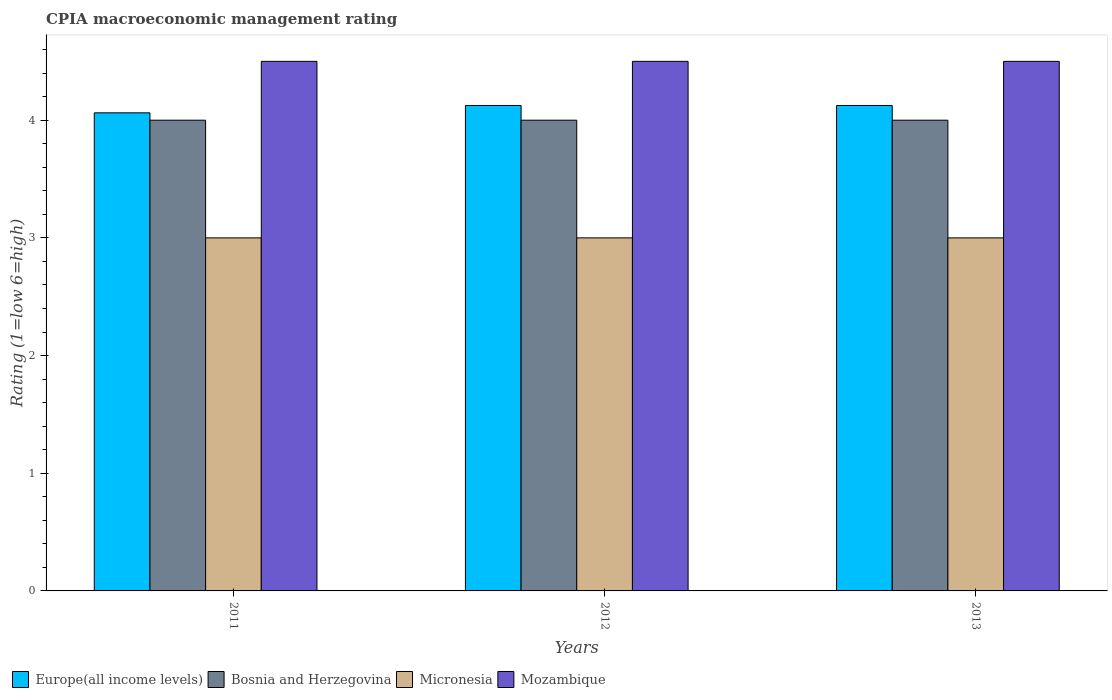Are the number of bars per tick equal to the number of legend labels?
Your answer should be compact. Yes. Are the number of bars on each tick of the X-axis equal?
Ensure brevity in your answer.  Yes. In how many cases, is the number of bars for a given year not equal to the number of legend labels?
Offer a very short reply. 0. What is the CPIA rating in Micronesia in 2011?
Your answer should be very brief. 3. Across all years, what is the maximum CPIA rating in Europe(all income levels)?
Provide a succinct answer. 4.12. What is the total CPIA rating in Bosnia and Herzegovina in the graph?
Provide a short and direct response. 12. What is the difference between the CPIA rating in Micronesia in 2011 and that in 2012?
Give a very brief answer. 0. What is the difference between the CPIA rating in Mozambique in 2012 and the CPIA rating in Micronesia in 2013?
Make the answer very short. 1.5. What is the average CPIA rating in Micronesia per year?
Your response must be concise. 3. In the year 2011, what is the difference between the CPIA rating in Bosnia and Herzegovina and CPIA rating in Europe(all income levels)?
Make the answer very short. -0.06. In how many years, is the CPIA rating in Bosnia and Herzegovina greater than 2.6?
Provide a short and direct response. 3. What is the difference between the highest and the second highest CPIA rating in Bosnia and Herzegovina?
Keep it short and to the point. 0. What is the difference between the highest and the lowest CPIA rating in Europe(all income levels)?
Offer a terse response. 0.06. In how many years, is the CPIA rating in Bosnia and Herzegovina greater than the average CPIA rating in Bosnia and Herzegovina taken over all years?
Your response must be concise. 0. Is it the case that in every year, the sum of the CPIA rating in Mozambique and CPIA rating in Bosnia and Herzegovina is greater than the sum of CPIA rating in Europe(all income levels) and CPIA rating in Micronesia?
Provide a short and direct response. Yes. What does the 2nd bar from the left in 2011 represents?
Offer a very short reply. Bosnia and Herzegovina. What does the 1st bar from the right in 2012 represents?
Make the answer very short. Mozambique. Is it the case that in every year, the sum of the CPIA rating in Mozambique and CPIA rating in Europe(all income levels) is greater than the CPIA rating in Bosnia and Herzegovina?
Your response must be concise. Yes. How many bars are there?
Offer a terse response. 12. How many years are there in the graph?
Ensure brevity in your answer.  3. Are the values on the major ticks of Y-axis written in scientific E-notation?
Your answer should be very brief. No. Does the graph contain grids?
Make the answer very short. No. Where does the legend appear in the graph?
Provide a succinct answer. Bottom left. What is the title of the graph?
Offer a terse response. CPIA macroeconomic management rating. Does "Lao PDR" appear as one of the legend labels in the graph?
Give a very brief answer. No. What is the label or title of the X-axis?
Your answer should be very brief. Years. What is the label or title of the Y-axis?
Provide a short and direct response. Rating (1=low 6=high). What is the Rating (1=low 6=high) of Europe(all income levels) in 2011?
Make the answer very short. 4.06. What is the Rating (1=low 6=high) of Europe(all income levels) in 2012?
Keep it short and to the point. 4.12. What is the Rating (1=low 6=high) in Micronesia in 2012?
Provide a short and direct response. 3. What is the Rating (1=low 6=high) in Europe(all income levels) in 2013?
Your answer should be very brief. 4.12. Across all years, what is the maximum Rating (1=low 6=high) of Europe(all income levels)?
Ensure brevity in your answer.  4.12. Across all years, what is the minimum Rating (1=low 6=high) of Europe(all income levels)?
Keep it short and to the point. 4.06. Across all years, what is the minimum Rating (1=low 6=high) in Bosnia and Herzegovina?
Keep it short and to the point. 4. What is the total Rating (1=low 6=high) in Europe(all income levels) in the graph?
Provide a succinct answer. 12.31. What is the total Rating (1=low 6=high) in Bosnia and Herzegovina in the graph?
Offer a terse response. 12. What is the total Rating (1=low 6=high) of Micronesia in the graph?
Your response must be concise. 9. What is the total Rating (1=low 6=high) in Mozambique in the graph?
Your response must be concise. 13.5. What is the difference between the Rating (1=low 6=high) in Europe(all income levels) in 2011 and that in 2012?
Make the answer very short. -0.06. What is the difference between the Rating (1=low 6=high) in Micronesia in 2011 and that in 2012?
Keep it short and to the point. 0. What is the difference between the Rating (1=low 6=high) of Mozambique in 2011 and that in 2012?
Provide a short and direct response. 0. What is the difference between the Rating (1=low 6=high) in Europe(all income levels) in 2011 and that in 2013?
Offer a terse response. -0.06. What is the difference between the Rating (1=low 6=high) of Bosnia and Herzegovina in 2011 and that in 2013?
Make the answer very short. 0. What is the difference between the Rating (1=low 6=high) of Micronesia in 2011 and that in 2013?
Offer a very short reply. 0. What is the difference between the Rating (1=low 6=high) in Europe(all income levels) in 2012 and that in 2013?
Offer a very short reply. 0. What is the difference between the Rating (1=low 6=high) of Bosnia and Herzegovina in 2012 and that in 2013?
Give a very brief answer. 0. What is the difference between the Rating (1=low 6=high) in Europe(all income levels) in 2011 and the Rating (1=low 6=high) in Bosnia and Herzegovina in 2012?
Keep it short and to the point. 0.06. What is the difference between the Rating (1=low 6=high) in Europe(all income levels) in 2011 and the Rating (1=low 6=high) in Mozambique in 2012?
Give a very brief answer. -0.44. What is the difference between the Rating (1=low 6=high) in Europe(all income levels) in 2011 and the Rating (1=low 6=high) in Bosnia and Herzegovina in 2013?
Your answer should be very brief. 0.06. What is the difference between the Rating (1=low 6=high) in Europe(all income levels) in 2011 and the Rating (1=low 6=high) in Micronesia in 2013?
Make the answer very short. 1.06. What is the difference between the Rating (1=low 6=high) of Europe(all income levels) in 2011 and the Rating (1=low 6=high) of Mozambique in 2013?
Offer a very short reply. -0.44. What is the difference between the Rating (1=low 6=high) in Bosnia and Herzegovina in 2011 and the Rating (1=low 6=high) in Micronesia in 2013?
Ensure brevity in your answer.  1. What is the difference between the Rating (1=low 6=high) of Europe(all income levels) in 2012 and the Rating (1=low 6=high) of Bosnia and Herzegovina in 2013?
Ensure brevity in your answer.  0.12. What is the difference between the Rating (1=low 6=high) in Europe(all income levels) in 2012 and the Rating (1=low 6=high) in Micronesia in 2013?
Provide a succinct answer. 1.12. What is the difference between the Rating (1=low 6=high) of Europe(all income levels) in 2012 and the Rating (1=low 6=high) of Mozambique in 2013?
Provide a short and direct response. -0.38. What is the difference between the Rating (1=low 6=high) in Micronesia in 2012 and the Rating (1=low 6=high) in Mozambique in 2013?
Provide a succinct answer. -1.5. What is the average Rating (1=low 6=high) of Europe(all income levels) per year?
Your answer should be compact. 4.1. In the year 2011, what is the difference between the Rating (1=low 6=high) of Europe(all income levels) and Rating (1=low 6=high) of Bosnia and Herzegovina?
Offer a very short reply. 0.06. In the year 2011, what is the difference between the Rating (1=low 6=high) of Europe(all income levels) and Rating (1=low 6=high) of Micronesia?
Provide a short and direct response. 1.06. In the year 2011, what is the difference between the Rating (1=low 6=high) of Europe(all income levels) and Rating (1=low 6=high) of Mozambique?
Give a very brief answer. -0.44. In the year 2011, what is the difference between the Rating (1=low 6=high) of Bosnia and Herzegovina and Rating (1=low 6=high) of Micronesia?
Your answer should be very brief. 1. In the year 2011, what is the difference between the Rating (1=low 6=high) in Bosnia and Herzegovina and Rating (1=low 6=high) in Mozambique?
Offer a terse response. -0.5. In the year 2012, what is the difference between the Rating (1=low 6=high) in Europe(all income levels) and Rating (1=low 6=high) in Micronesia?
Provide a short and direct response. 1.12. In the year 2012, what is the difference between the Rating (1=low 6=high) in Europe(all income levels) and Rating (1=low 6=high) in Mozambique?
Provide a succinct answer. -0.38. In the year 2012, what is the difference between the Rating (1=low 6=high) in Bosnia and Herzegovina and Rating (1=low 6=high) in Micronesia?
Your answer should be compact. 1. In the year 2012, what is the difference between the Rating (1=low 6=high) in Micronesia and Rating (1=low 6=high) in Mozambique?
Make the answer very short. -1.5. In the year 2013, what is the difference between the Rating (1=low 6=high) of Europe(all income levels) and Rating (1=low 6=high) of Bosnia and Herzegovina?
Your answer should be compact. 0.12. In the year 2013, what is the difference between the Rating (1=low 6=high) of Europe(all income levels) and Rating (1=low 6=high) of Mozambique?
Ensure brevity in your answer.  -0.38. In the year 2013, what is the difference between the Rating (1=low 6=high) in Bosnia and Herzegovina and Rating (1=low 6=high) in Mozambique?
Your response must be concise. -0.5. In the year 2013, what is the difference between the Rating (1=low 6=high) of Micronesia and Rating (1=low 6=high) of Mozambique?
Keep it short and to the point. -1.5. What is the ratio of the Rating (1=low 6=high) in Micronesia in 2011 to that in 2012?
Your answer should be very brief. 1. What is the ratio of the Rating (1=low 6=high) of Mozambique in 2011 to that in 2013?
Make the answer very short. 1. What is the ratio of the Rating (1=low 6=high) of Bosnia and Herzegovina in 2012 to that in 2013?
Offer a terse response. 1. What is the ratio of the Rating (1=low 6=high) of Micronesia in 2012 to that in 2013?
Your response must be concise. 1. What is the difference between the highest and the second highest Rating (1=low 6=high) in Bosnia and Herzegovina?
Your response must be concise. 0. What is the difference between the highest and the second highest Rating (1=low 6=high) in Micronesia?
Keep it short and to the point. 0. What is the difference between the highest and the second highest Rating (1=low 6=high) of Mozambique?
Your response must be concise. 0. What is the difference between the highest and the lowest Rating (1=low 6=high) of Europe(all income levels)?
Offer a very short reply. 0.06. What is the difference between the highest and the lowest Rating (1=low 6=high) in Mozambique?
Provide a succinct answer. 0. 